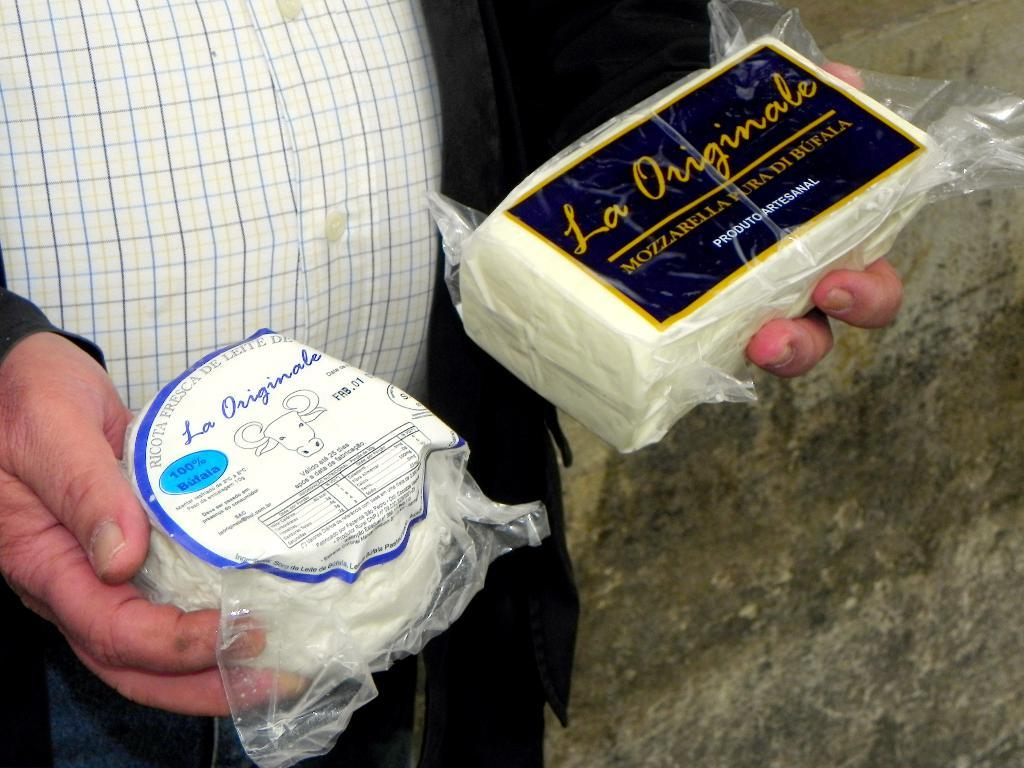What is the main subject of the image? There is a person in the image. What is the person doing in the image? The person is holding two food items in their hands. Can you describe the person's clothing in the image? The person is wearing a checkered shirt. What type of waves can be seen in the background of the image? There are no waves visible in the image; it features a person holding food items and wearing a checkered shirt. 